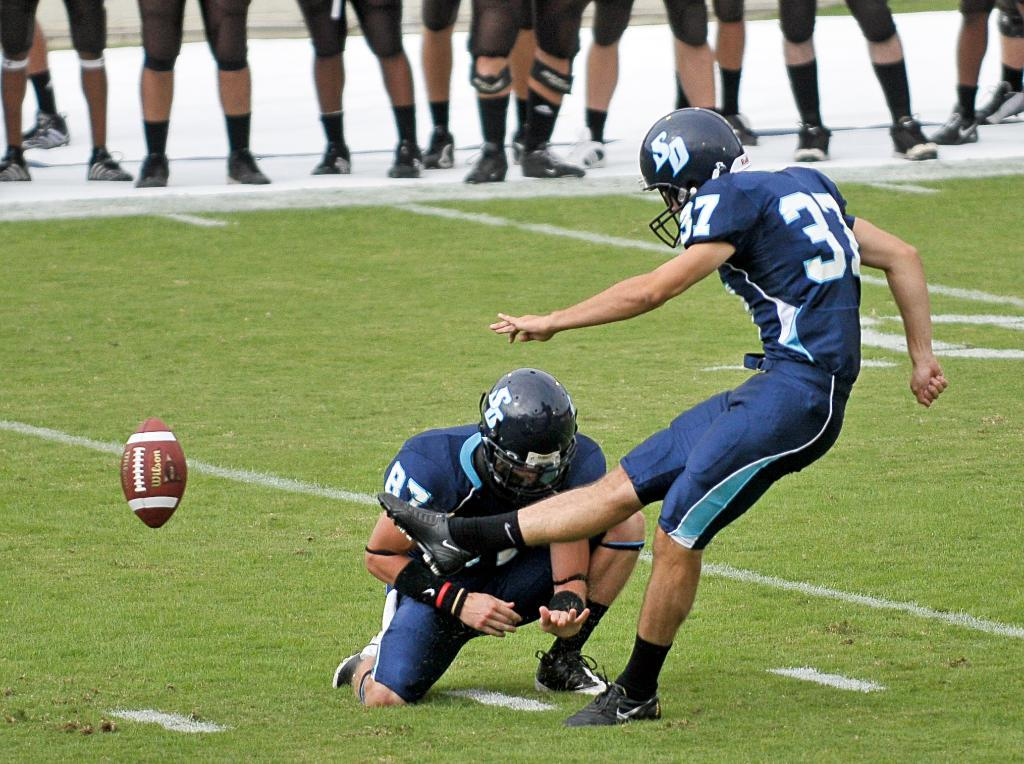How many people are in the image? There is a group of persons in the image. What is the position of the persons in the image? The persons are standing on the ground. Can you describe the attire of one of the persons? One person is wearing a blue dress and helmet. What object can be seen on the left side of the image? There is a ball on the left side of the image. What type of seat is the person wearing in the image? The person is not wearing a seat; they are wearing a blue dress and helmet. How does the digestion of the persons in the image appear to be affected by the presence of the ball? There is no information about the digestion of the persons in the image, and the presence of the ball does not affect it. 